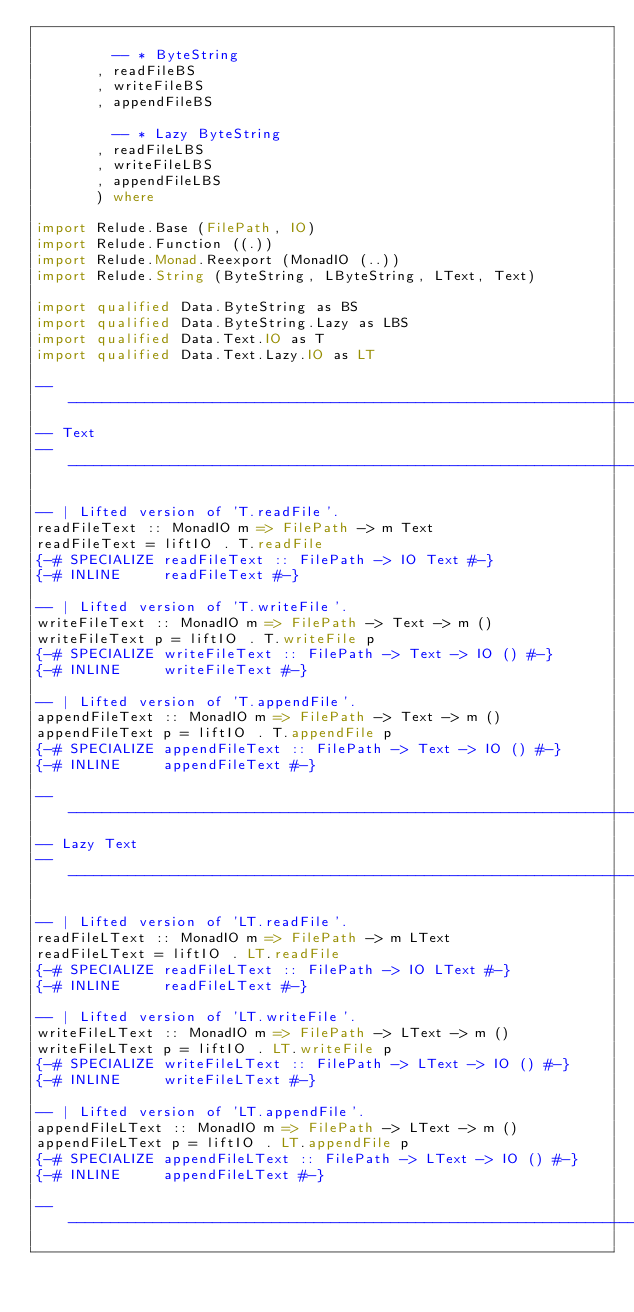<code> <loc_0><loc_0><loc_500><loc_500><_Haskell_>
         -- * ByteString
       , readFileBS
       , writeFileBS
       , appendFileBS

         -- * Lazy ByteString
       , readFileLBS
       , writeFileLBS
       , appendFileLBS
       ) where

import Relude.Base (FilePath, IO)
import Relude.Function ((.))
import Relude.Monad.Reexport (MonadIO (..))
import Relude.String (ByteString, LByteString, LText, Text)

import qualified Data.ByteString as BS
import qualified Data.ByteString.Lazy as LBS
import qualified Data.Text.IO as T
import qualified Data.Text.Lazy.IO as LT

----------------------------------------------------------------------------
-- Text
----------------------------------------------------------------------------

-- | Lifted version of 'T.readFile'.
readFileText :: MonadIO m => FilePath -> m Text
readFileText = liftIO . T.readFile
{-# SPECIALIZE readFileText :: FilePath -> IO Text #-}
{-# INLINE     readFileText #-}

-- | Lifted version of 'T.writeFile'.
writeFileText :: MonadIO m => FilePath -> Text -> m ()
writeFileText p = liftIO . T.writeFile p
{-# SPECIALIZE writeFileText :: FilePath -> Text -> IO () #-}
{-# INLINE     writeFileText #-}

-- | Lifted version of 'T.appendFile'.
appendFileText :: MonadIO m => FilePath -> Text -> m ()
appendFileText p = liftIO . T.appendFile p
{-# SPECIALIZE appendFileText :: FilePath -> Text -> IO () #-}
{-# INLINE     appendFileText #-}

----------------------------------------------------------------------------
-- Lazy Text
----------------------------------------------------------------------------

-- | Lifted version of 'LT.readFile'.
readFileLText :: MonadIO m => FilePath -> m LText
readFileLText = liftIO . LT.readFile
{-# SPECIALIZE readFileLText :: FilePath -> IO LText #-}
{-# INLINE     readFileLText #-}

-- | Lifted version of 'LT.writeFile'.
writeFileLText :: MonadIO m => FilePath -> LText -> m ()
writeFileLText p = liftIO . LT.writeFile p
{-# SPECIALIZE writeFileLText :: FilePath -> LText -> IO () #-}
{-# INLINE     writeFileLText #-}

-- | Lifted version of 'LT.appendFile'.
appendFileLText :: MonadIO m => FilePath -> LText -> m ()
appendFileLText p = liftIO . LT.appendFile p
{-# SPECIALIZE appendFileLText :: FilePath -> LText -> IO () #-}
{-# INLINE     appendFileLText #-}

----------------------------------------------------------------------------</code> 